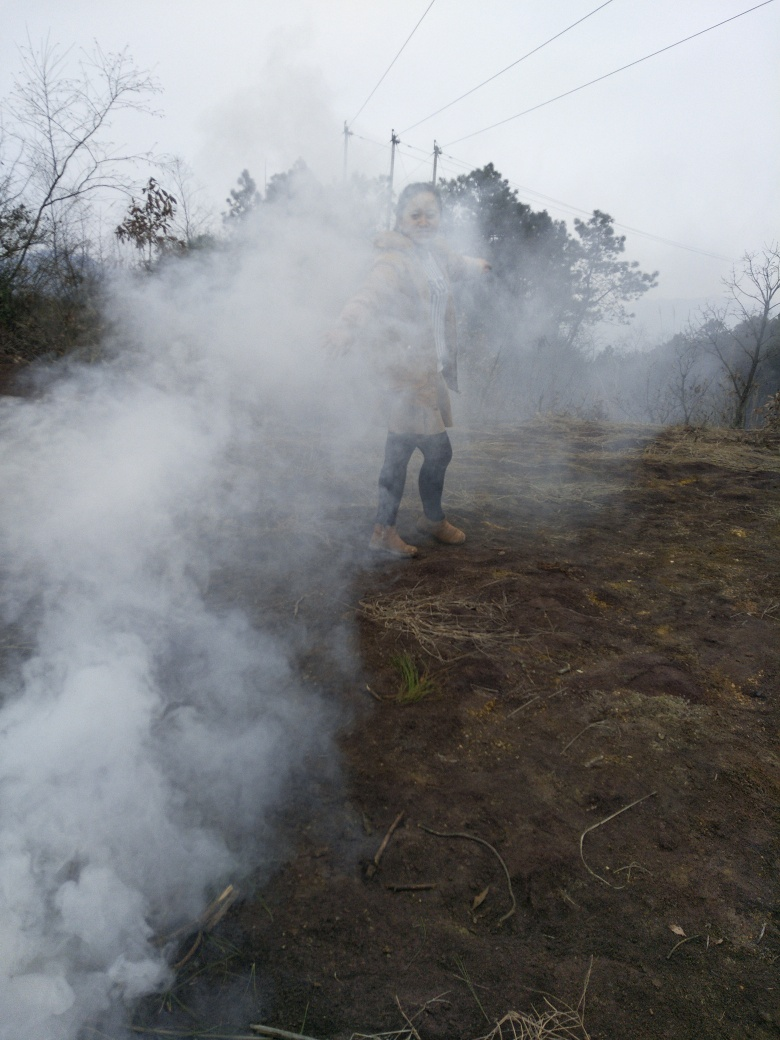How might the person in the image be feeling with all the smoke around? While I cannot accurately ascertain emotions, the person appears to be partially covered by the smoke which might make breathing uncomfortable. Depending on the person's reason for being in the area, they might feel anything from annoyance at the smoke to fascination or interest if they are monitoring or controlling the source of the smoke. The presence of smoke might also impart a sense of urgency or caution if it represents a change from normal conditions. 